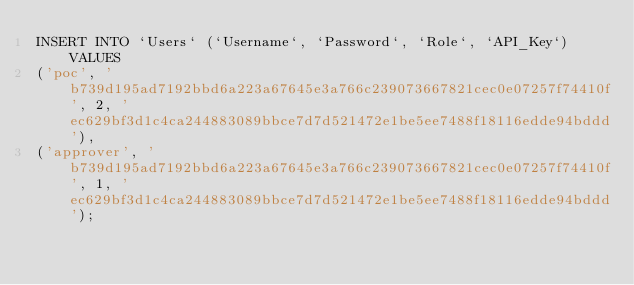<code> <loc_0><loc_0><loc_500><loc_500><_SQL_>INSERT INTO `Users` (`Username`, `Password`, `Role`, `API_Key`) VALUES 
('poc', 'b739d195ad7192bbd6a223a67645e3a766c239073667821cec0e07257f74410f', 2, 'ec629bf3d1c4ca244883089bbce7d7d521472e1be5ee7488f18116edde94bddd'),
('approver', 'b739d195ad7192bbd6a223a67645e3a766c239073667821cec0e07257f74410f', 1, 'ec629bf3d1c4ca244883089bbce7d7d521472e1be5ee7488f18116edde94bddd');</code> 